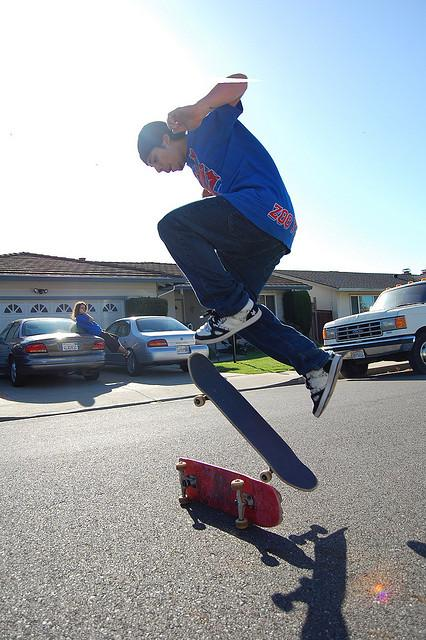What type of skateboarding would this be considered? Please explain your reasoning. street. The person is skating near cars in driveways. 